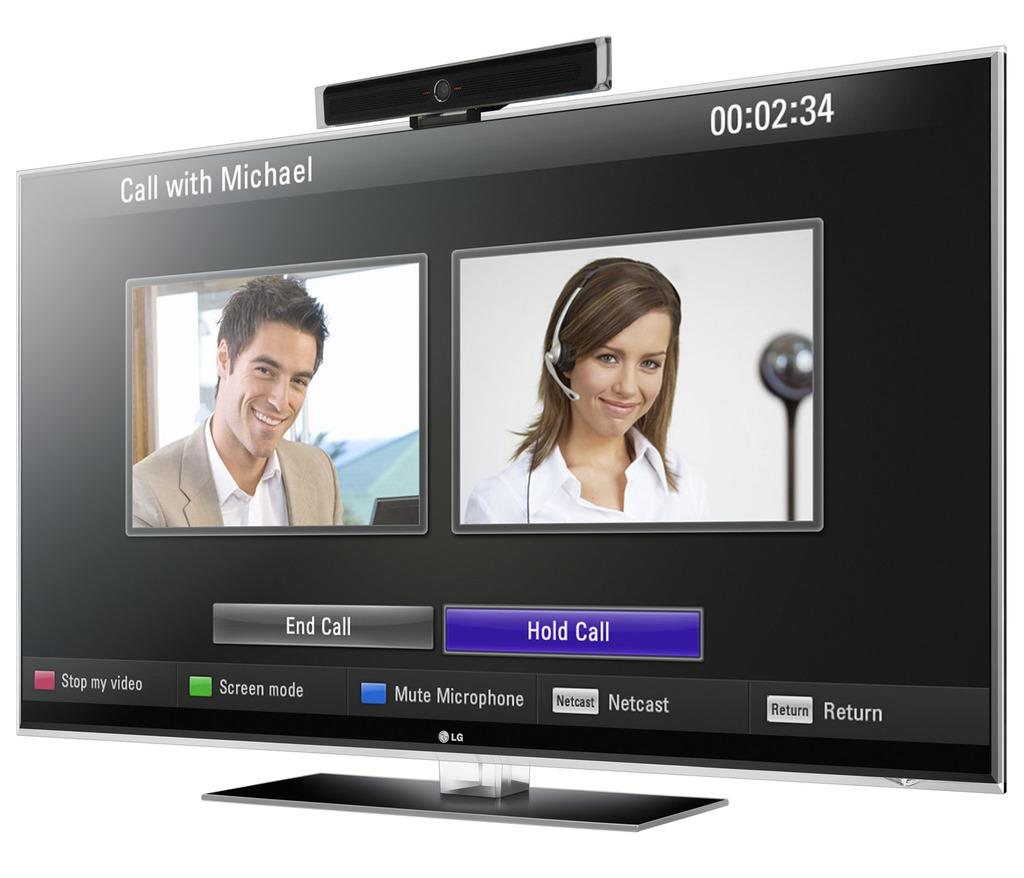<image>
Give a short and clear explanation of the subsequent image. A conference call software is displayed on a monitor. 